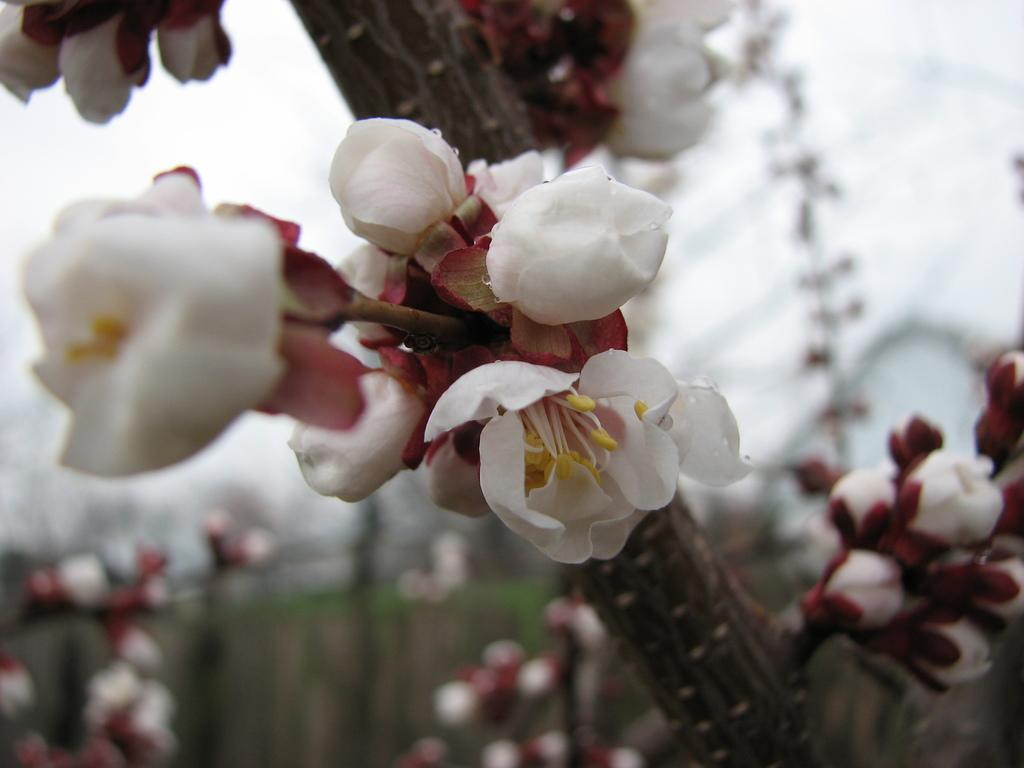What type of living organisms can be seen in the image? There are flowers in the image. What type of noise can be heard coming from the flowers in the image? There is no noise coming from the flowers in the image, as flowers do not produce sound. 